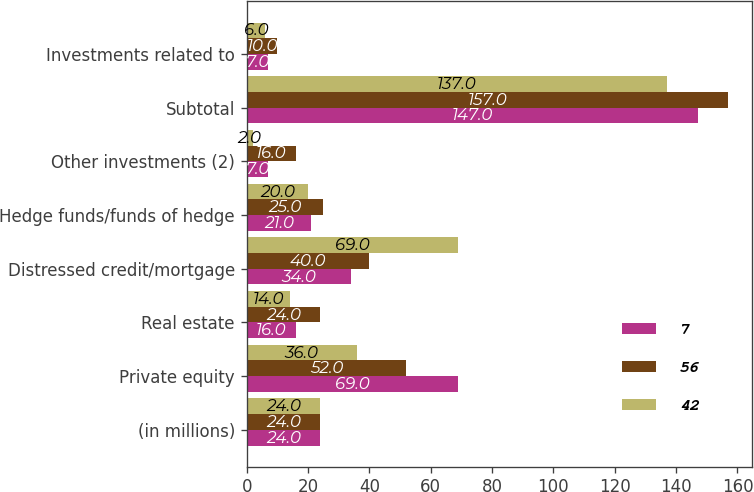Convert chart to OTSL. <chart><loc_0><loc_0><loc_500><loc_500><stacked_bar_chart><ecel><fcel>(in millions)<fcel>Private equity<fcel>Real estate<fcel>Distressed credit/mortgage<fcel>Hedge funds/funds of hedge<fcel>Other investments (2)<fcel>Subtotal<fcel>Investments related to<nl><fcel>7<fcel>24<fcel>69<fcel>16<fcel>34<fcel>21<fcel>7<fcel>147<fcel>7<nl><fcel>56<fcel>24<fcel>52<fcel>24<fcel>40<fcel>25<fcel>16<fcel>157<fcel>10<nl><fcel>42<fcel>24<fcel>36<fcel>14<fcel>69<fcel>20<fcel>2<fcel>137<fcel>6<nl></chart> 